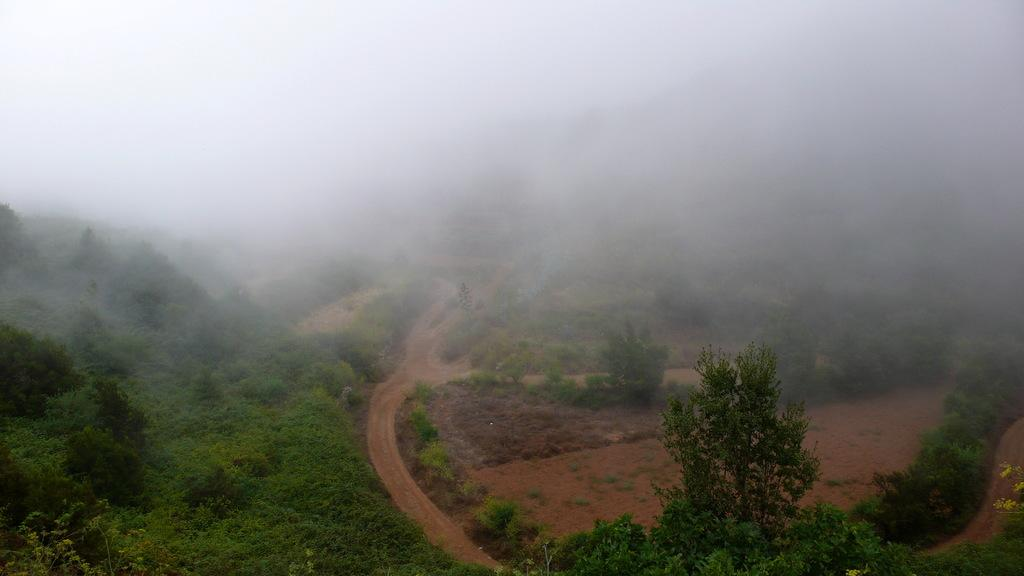What is the main feature of the image? There is a road in the image. What can be seen on the hill in the image? Plants and trees are present on a hill. What type of vegetation is near the dry land on the right side of the image? There are trees and plants near dry land on the right side of the image. What is visible in the background of the image? Snow smoke is visible in the background of the image. How far does the reason travel in the image? There is no reason present in the image, as it is not a physical object or entity. 